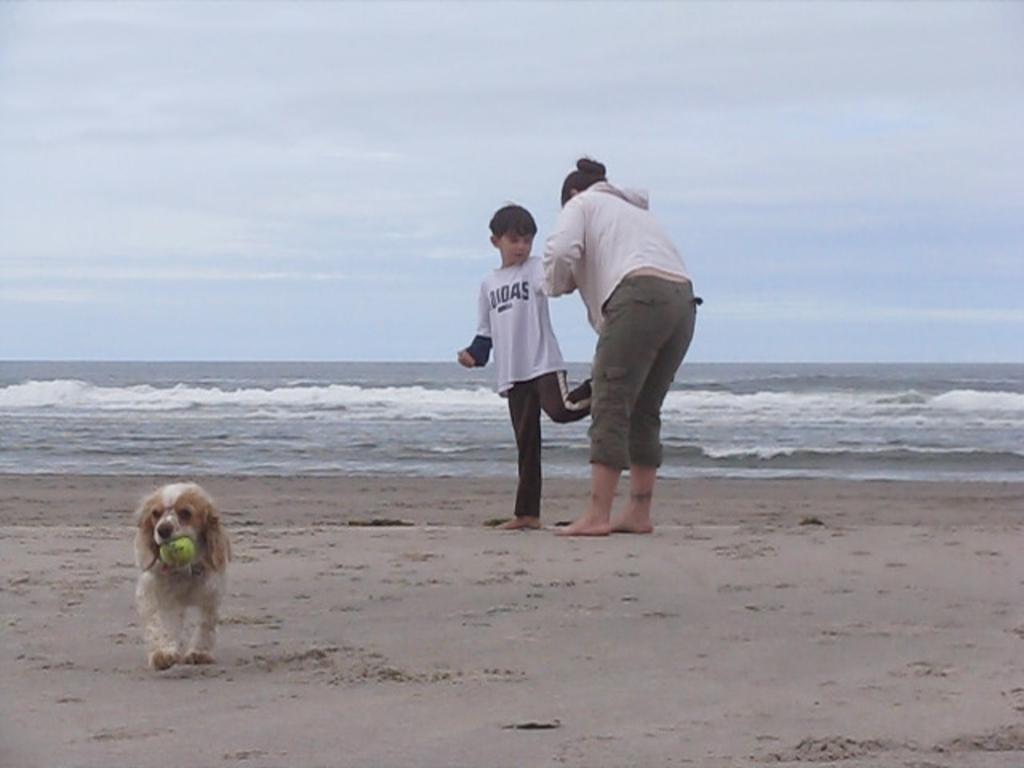Could you give a brief overview of what you see in this image? In the image there is a sea, in front of the sea shore there are two people and on the left side there is a dog holding a ball with its mouth. 